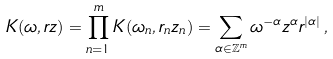Convert formula to latex. <formula><loc_0><loc_0><loc_500><loc_500>K ( \omega , r z ) = \prod _ { n = 1 } ^ { m } K ( \omega _ { n } , r _ { n } z _ { n } ) = \sum _ { \alpha \in \mathbb { Z } ^ { m } } \omega ^ { - \alpha } z ^ { \alpha } r ^ { | \alpha | } \, ,</formula> 